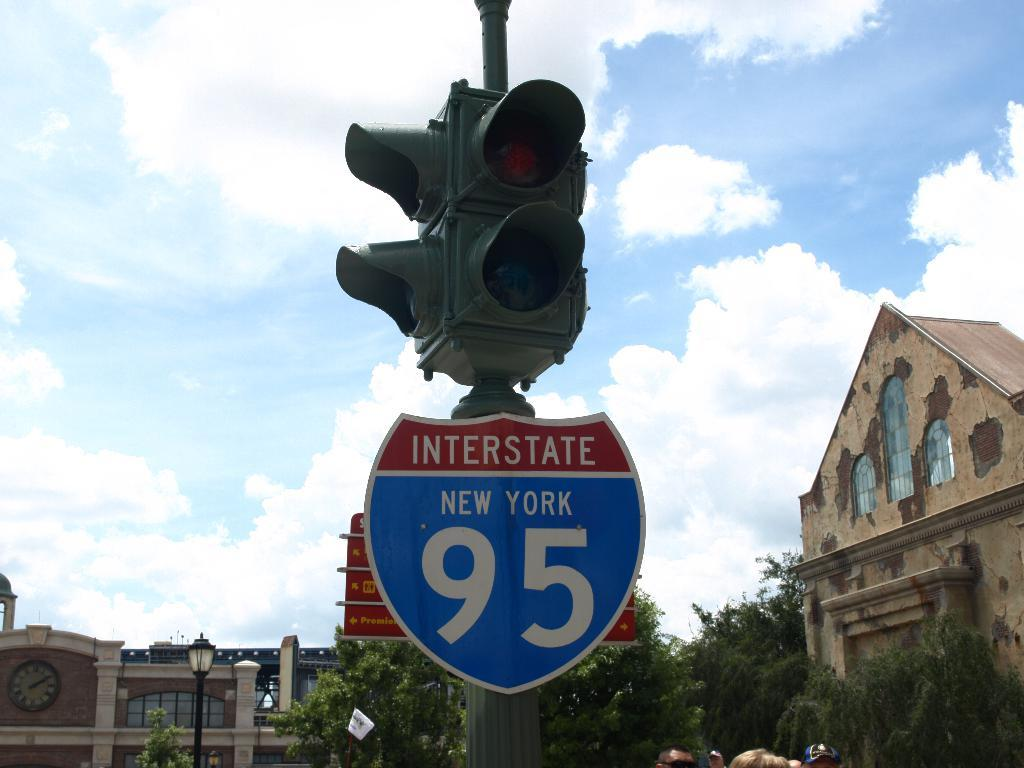<image>
Render a clear and concise summary of the photo. Interstate 95 is on a sign that is below a light 